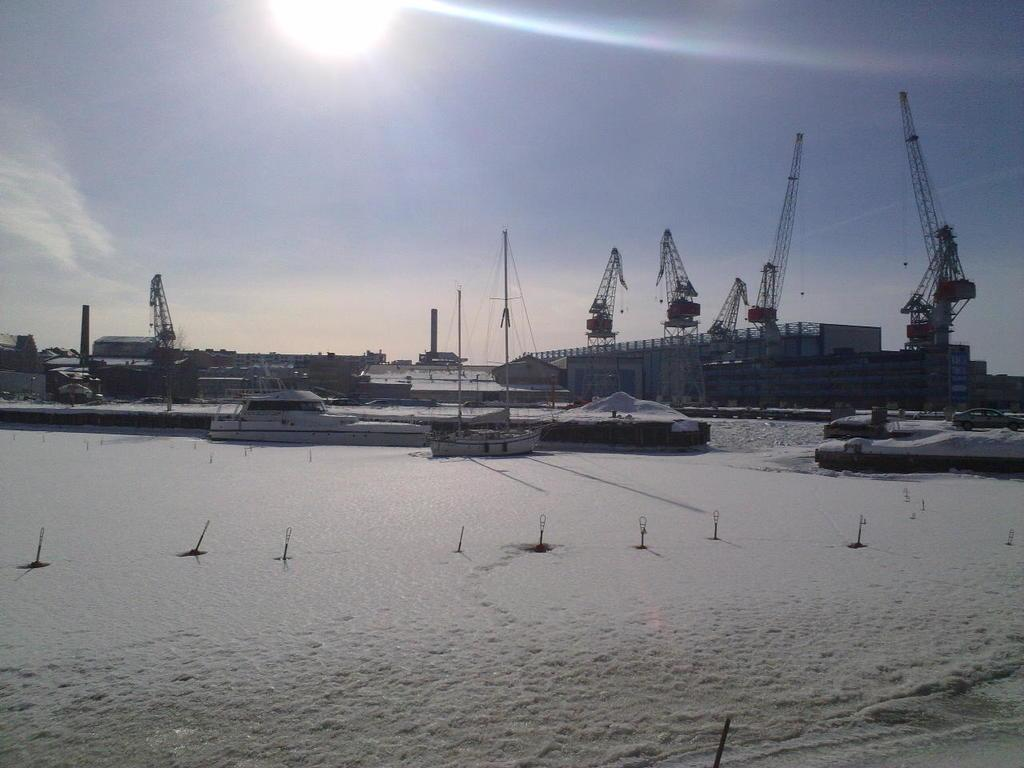What type of watercraft can be seen in the image? There is a ship and a boat in the image. Where are the ship and boat located in the image? Both the ship and boat are on snow in the image. What else can be seen in the image besides the watercraft? There is a vehicle on the road, cranes, buildings in the background, and the sky with the sun is visible at the top of the image. How many laborers are working on the ship in the image? There are no laborers visible on the ship in the image. In which direction is the ship facing in the image, north or south? The direction the ship is facing cannot be determined from the image. 